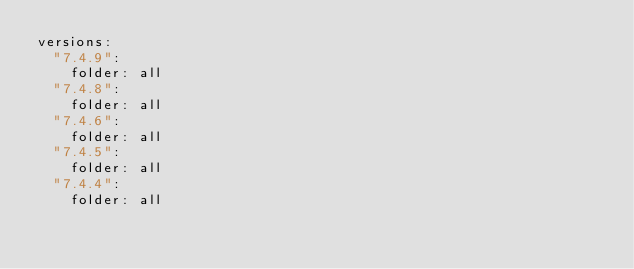Convert code to text. <code><loc_0><loc_0><loc_500><loc_500><_YAML_>versions:
  "7.4.9":
    folder: all
  "7.4.8":
    folder: all
  "7.4.6":
    folder: all
  "7.4.5":
    folder: all
  "7.4.4":
    folder: all
</code> 